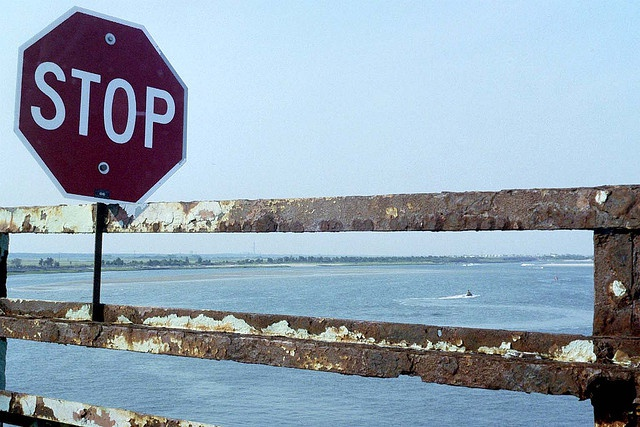Describe the objects in this image and their specific colors. I can see stop sign in lightblue and purple tones and boat in lightblue, gray, darkblue, and navy tones in this image. 